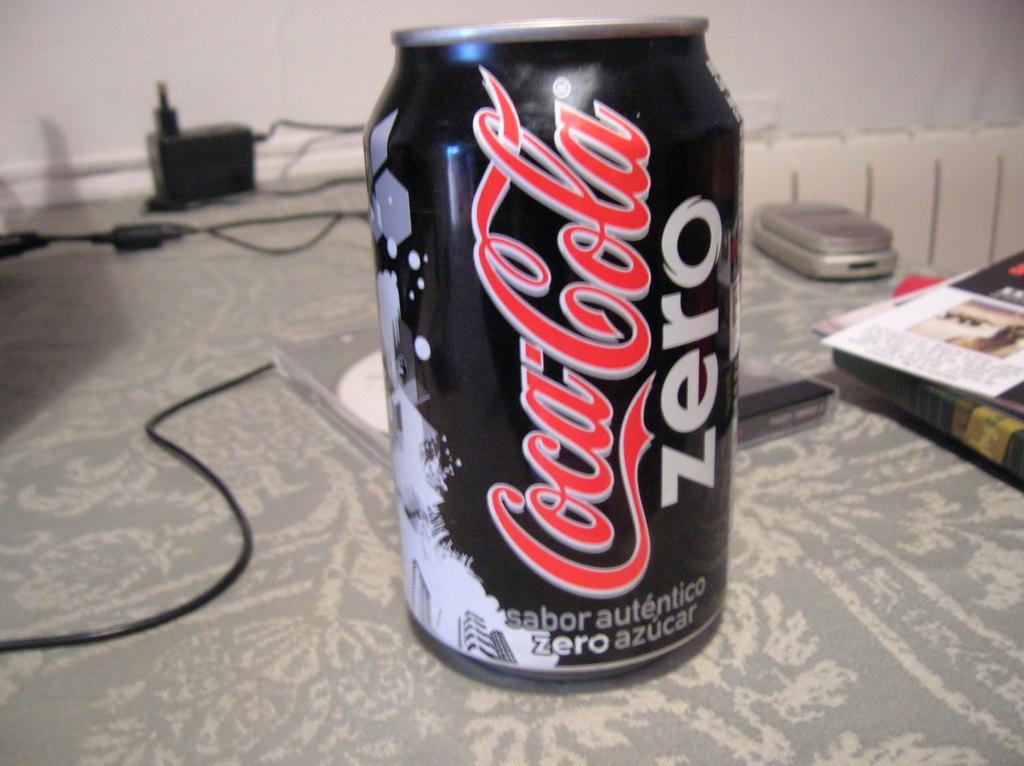Does this soda contain sugar?
Your answer should be compact. No. 